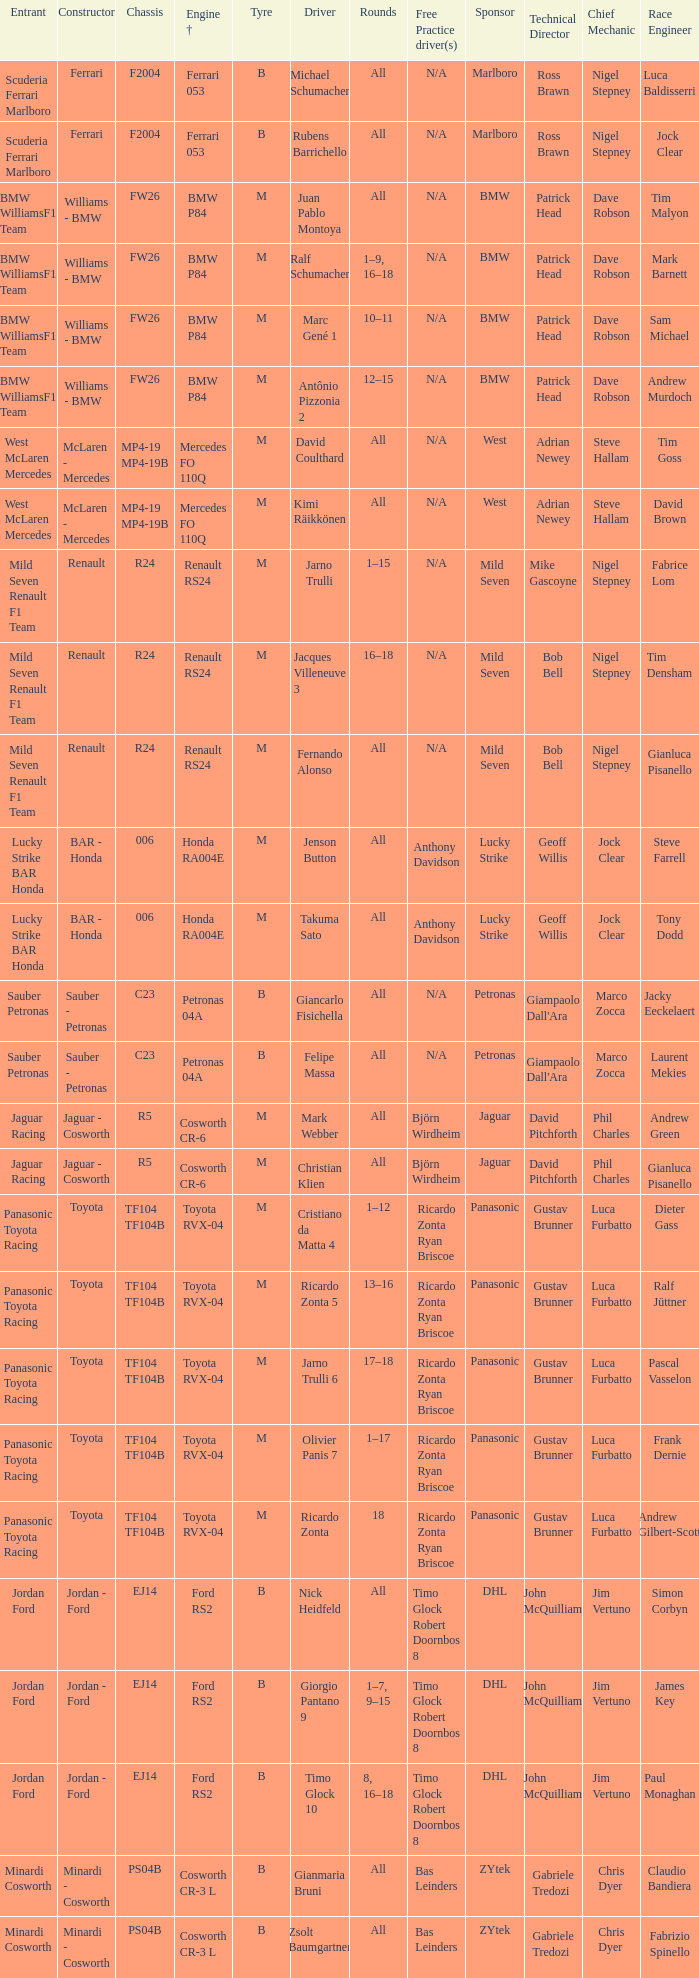What are the cycles for the b tires and ferrari 053 motor +? All, All. 